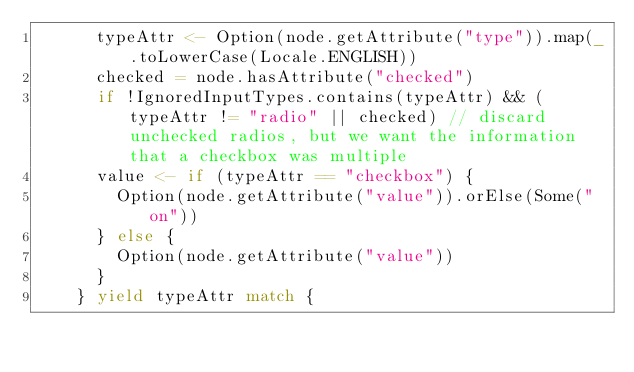<code> <loc_0><loc_0><loc_500><loc_500><_Scala_>      typeAttr <- Option(node.getAttribute("type")).map(_.toLowerCase(Locale.ENGLISH))
      checked = node.hasAttribute("checked")
      if !IgnoredInputTypes.contains(typeAttr) && (typeAttr != "radio" || checked) // discard unchecked radios, but we want the information that a checkbox was multiple
      value <- if (typeAttr == "checkbox") {
        Option(node.getAttribute("value")).orElse(Some("on"))
      } else {
        Option(node.getAttribute("value"))
      }
    } yield typeAttr match {</code> 